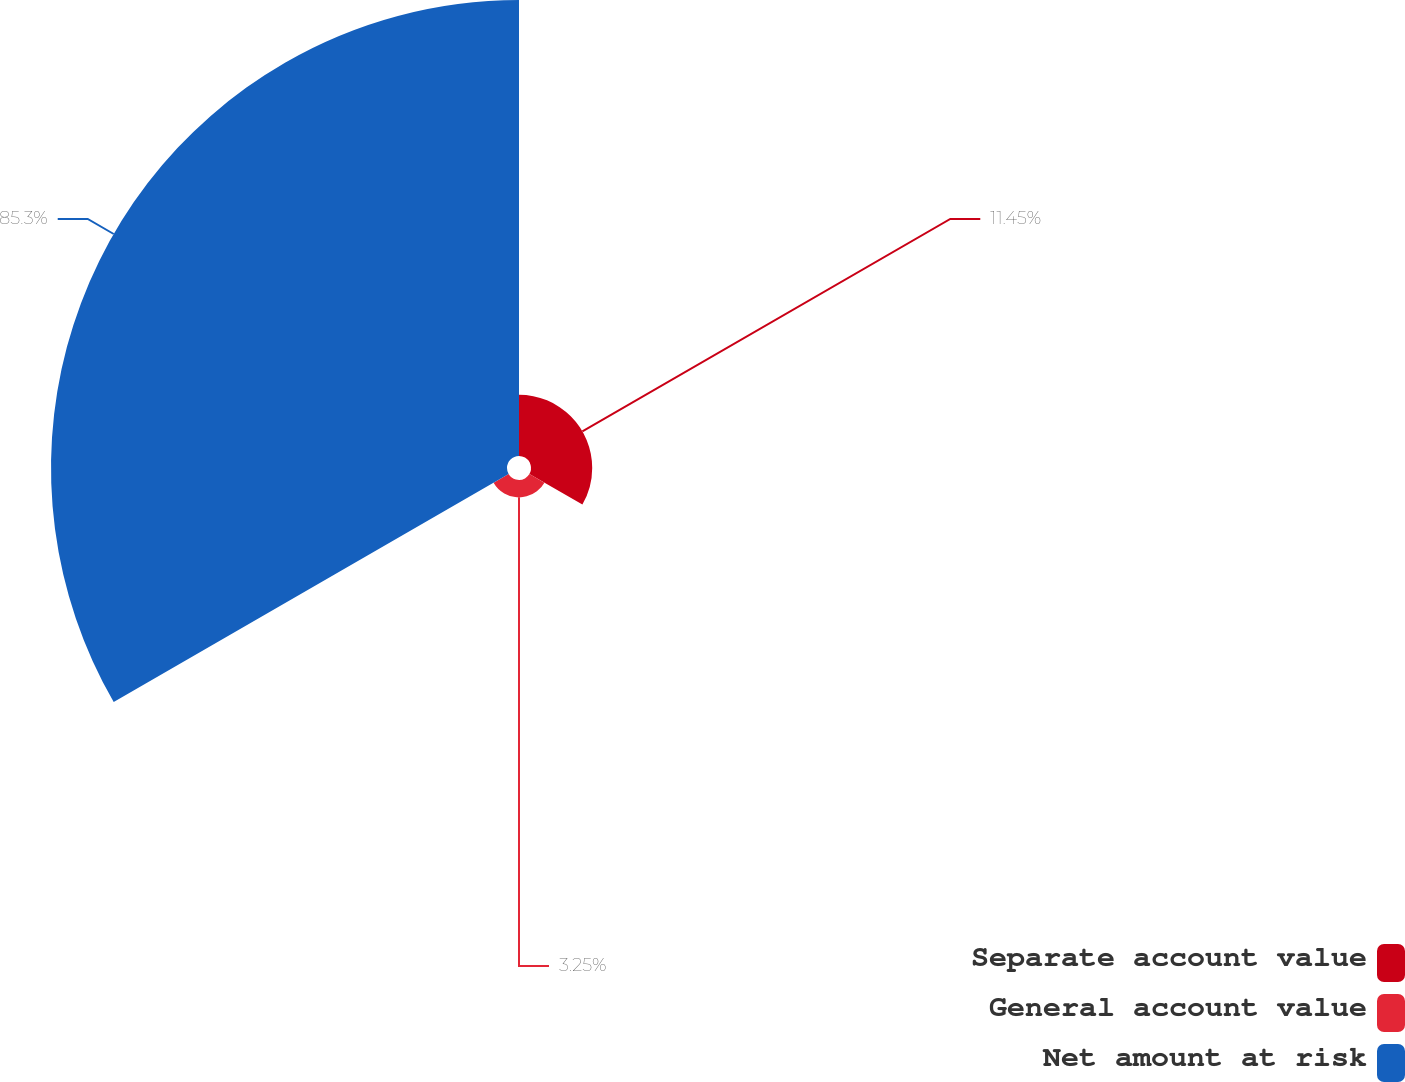<chart> <loc_0><loc_0><loc_500><loc_500><pie_chart><fcel>Separate account value<fcel>General account value<fcel>Net amount at risk<nl><fcel>11.45%<fcel>3.25%<fcel>85.3%<nl></chart> 